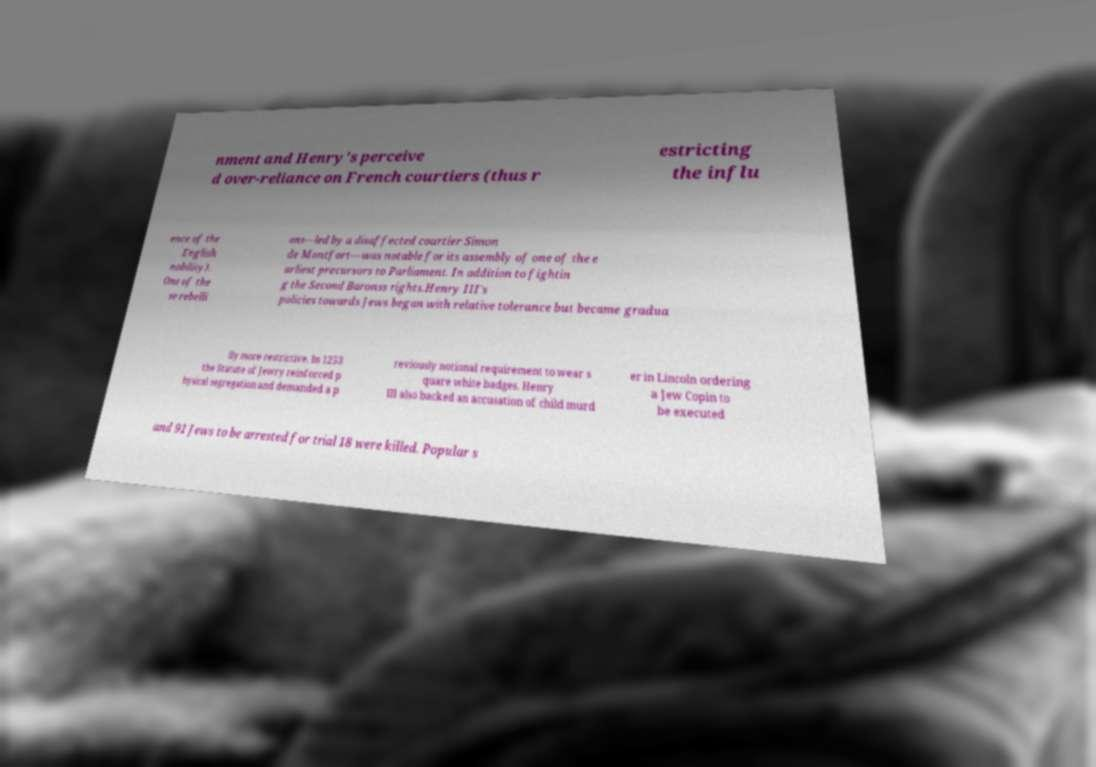For documentation purposes, I need the text within this image transcribed. Could you provide that? nment and Henry's perceive d over-reliance on French courtiers (thus r estricting the influ ence of the English nobility). One of the se rebelli ons—led by a disaffected courtier Simon de Montfort—was notable for its assembly of one of the e arliest precursors to Parliament. In addition to fightin g the Second Baronss rights.Henry III's policies towards Jews began with relative tolerance but became gradua lly more restrictive. In 1253 the Statute of Jewry reinforced p hysical segregation and demanded a p reviously notional requirement to wear s quare white badges. Henry III also backed an accusation of child murd er in Lincoln ordering a Jew Copin to be executed and 91 Jews to be arrested for trial 18 were killed. Popular s 